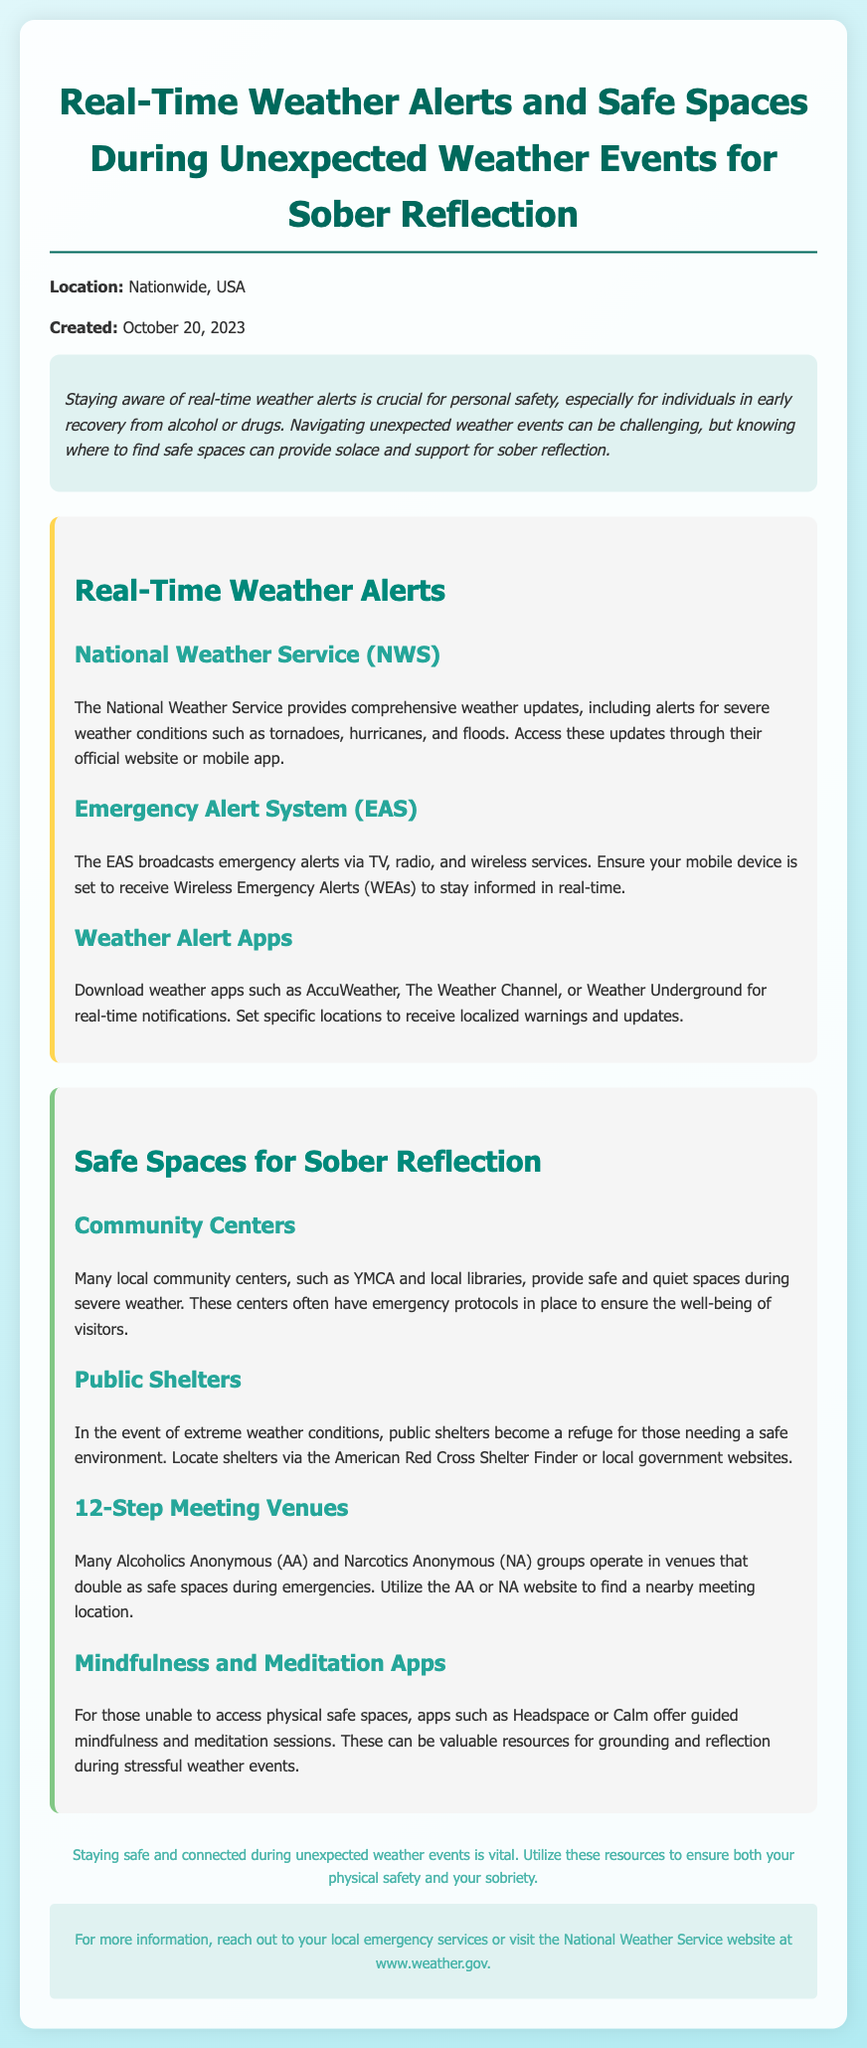What is the title of the document? The title of the document, as stated in the header section, provides context for the content within.
Answer: Real-Time Weather Alerts and Safe Spaces During Unexpected Weather Events for Sober Reflection When was the document created? The creation date is explicitly mentioned in the header section which offers insights into the timeliness of the information.
Answer: October 20, 2023 Which agency provides comprehensive weather updates? The document specifies the agency responsible for offering weather alerts, crucial for personal safety.
Answer: National Weather Service What type of emergency alerts can be received through mobile devices? This information highlights the necessity of staying informed about emergencies via technology, as mentioned in the alerts section.
Answer: Wireless Emergency Alerts Name one type of safe space mentioned for sober reflection. The document lists various safe spaces that are critical during unexpected weather events, particularly for individuals in recovery.
Answer: Community Centers Which apps are suggested for guided mindfulness during weather events? The inclusion of this information shows the document’s emphasis on mental well-being during stressful situations.
Answer: Headspace or Calm What is the purpose of public shelters during extreme weather? The document describes the role of public shelters in providing safety during adverse weather conditions.
Answer: Refuge Where can one find information about local shelters? The document provides resources for finding safe havens, emphasizing the importance of community support during emergencies.
Answer: American Red Cross Shelter Finder What type of venues also serve as safe spaces during emergencies? The document highlights additional venues that provide safe environments, which is vital for those in recovery.
Answer: 12-Step Meeting Venues 